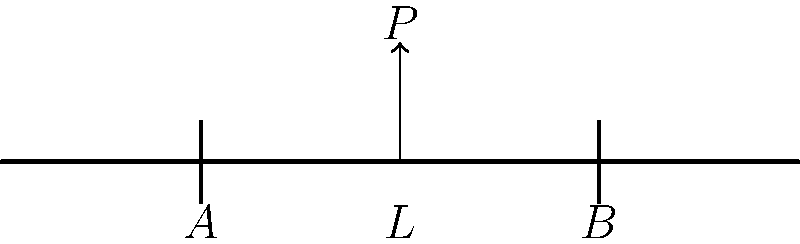A simply supported beam of length $L$ is subjected to a concentrated load $P$ at its midpoint. If the supports are located at points $A$ and $B$, determine the reaction forces at these supports. To solve this problem, we'll follow these steps:

1) First, we need to understand that for a beam in static equilibrium, the sum of all forces and moments must equal zero.

2) Let's denote the reaction forces at supports $A$ and $B$ as $R_A$ and $R_B$ respectively.

3) The sum of vertical forces must equal zero:
   $$R_A + R_B - P = 0$$

4) The sum of moments about any point must be zero. Let's take moments about point $A$:
   $$R_B \cdot L - P \cdot \frac{L}{2} = 0$$

5) From the moment equation, we can find $R_B$:
   $$R_B = \frac{P \cdot \frac{L}{2}}{L} = \frac{P}{2}$$

6) Substituting this into the force equation:
   $$R_A + \frac{P}{2} - P = 0$$
   $$R_A = \frac{P}{2}$$

7) Therefore, due to the symmetry of the problem, both reaction forces are equal to half the applied load.
Answer: $R_A = R_B = \frac{P}{2}$ 